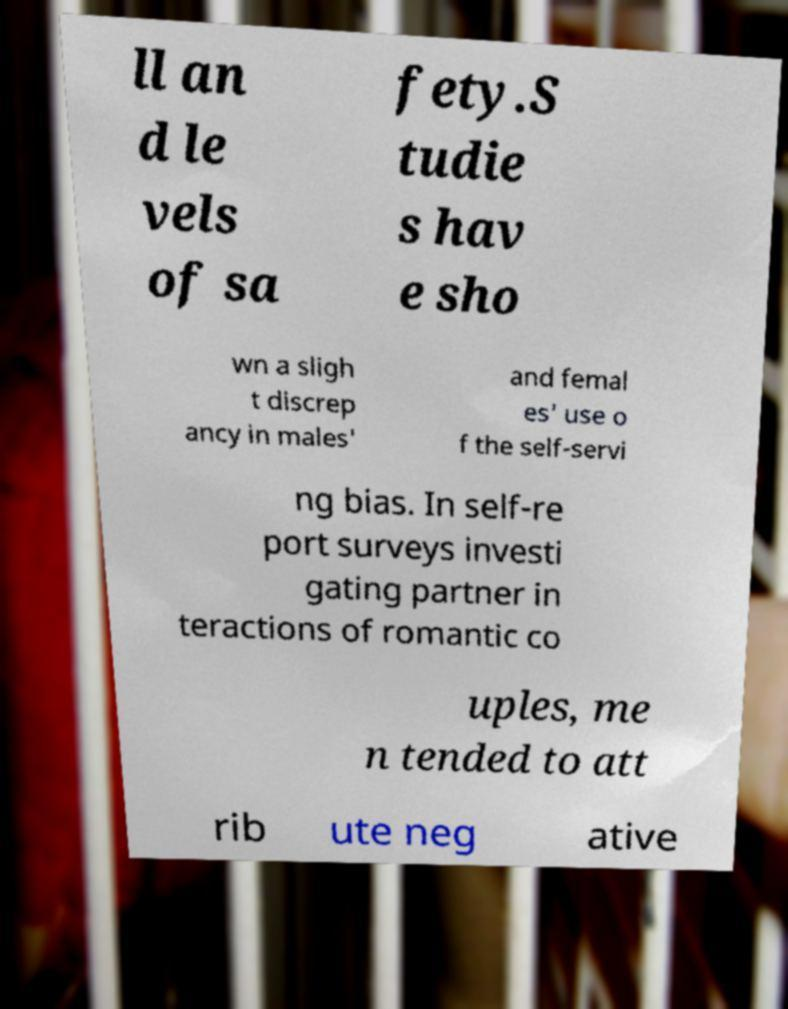There's text embedded in this image that I need extracted. Can you transcribe it verbatim? ll an d le vels of sa fety.S tudie s hav e sho wn a sligh t discrep ancy in males' and femal es' use o f the self-servi ng bias. In self-re port surveys investi gating partner in teractions of romantic co uples, me n tended to att rib ute neg ative 